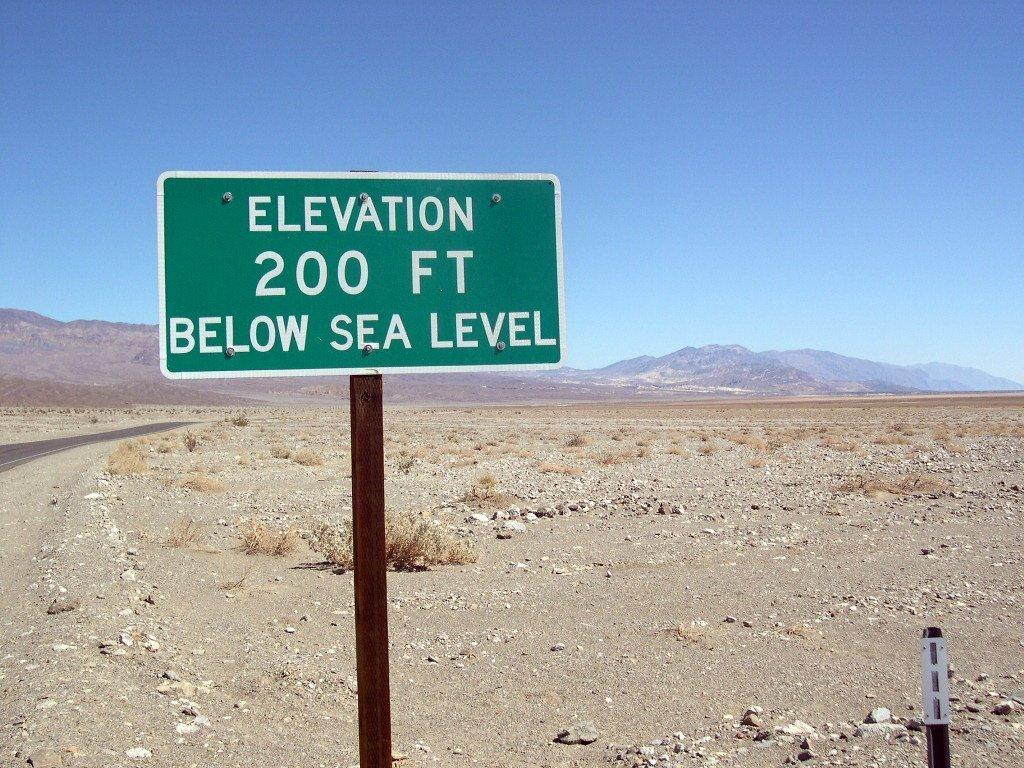Provide a one-sentence caption for the provided image. A green sign with the words Elevation 200 ft below sea level on it. 